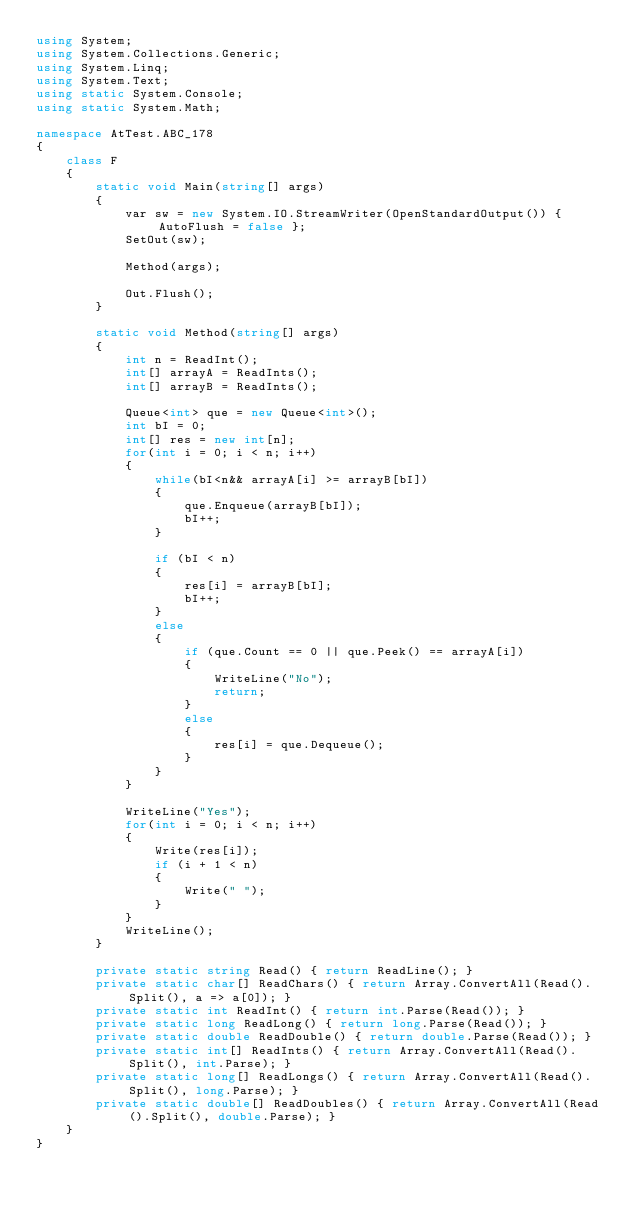Convert code to text. <code><loc_0><loc_0><loc_500><loc_500><_C#_>using System;
using System.Collections.Generic;
using System.Linq;
using System.Text;
using static System.Console;
using static System.Math;

namespace AtTest.ABC_178
{
    class F
    {
        static void Main(string[] args)
        {
            var sw = new System.IO.StreamWriter(OpenStandardOutput()) { AutoFlush = false };
            SetOut(sw);

            Method(args);

            Out.Flush();
        }

        static void Method(string[] args)
        {
            int n = ReadInt();
            int[] arrayA = ReadInts();
            int[] arrayB = ReadInts();

            Queue<int> que = new Queue<int>();
            int bI = 0;
            int[] res = new int[n];
            for(int i = 0; i < n; i++)
            {
                while(bI<n&& arrayA[i] >= arrayB[bI])
                {
                    que.Enqueue(arrayB[bI]);
                    bI++;
                }

                if (bI < n)
                {
                    res[i] = arrayB[bI];
                    bI++;
                }
                else
                {
                    if (que.Count == 0 || que.Peek() == arrayA[i])
                    {
                        WriteLine("No");
                        return;
                    }
                    else
                    {
                        res[i] = que.Dequeue();
                    }
                }
            }

            WriteLine("Yes");
            for(int i = 0; i < n; i++)
            {
                Write(res[i]);
                if (i + 1 < n)
                {
                    Write(" ");
                }
            }
            WriteLine();
        }

        private static string Read() { return ReadLine(); }
        private static char[] ReadChars() { return Array.ConvertAll(Read().Split(), a => a[0]); }
        private static int ReadInt() { return int.Parse(Read()); }
        private static long ReadLong() { return long.Parse(Read()); }
        private static double ReadDouble() { return double.Parse(Read()); }
        private static int[] ReadInts() { return Array.ConvertAll(Read().Split(), int.Parse); }
        private static long[] ReadLongs() { return Array.ConvertAll(Read().Split(), long.Parse); }
        private static double[] ReadDoubles() { return Array.ConvertAll(Read().Split(), double.Parse); }
    }
}
</code> 